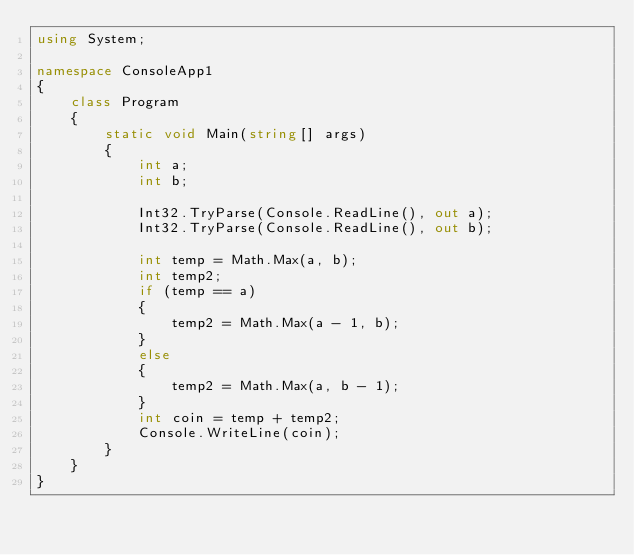<code> <loc_0><loc_0><loc_500><loc_500><_C#_>using System;

namespace ConsoleApp1
{
    class Program
    {
        static void Main(string[] args)
        {
            int a;
            int b;

            Int32.TryParse(Console.ReadLine(), out a);
            Int32.TryParse(Console.ReadLine(), out b);

            int temp = Math.Max(a, b);
            int temp2;
            if (temp == a)
            {
                temp2 = Math.Max(a - 1, b);
            }
            else
            {
                temp2 = Math.Max(a, b - 1);
            }
            int coin = temp + temp2;
            Console.WriteLine(coin);
        }
    }
}</code> 